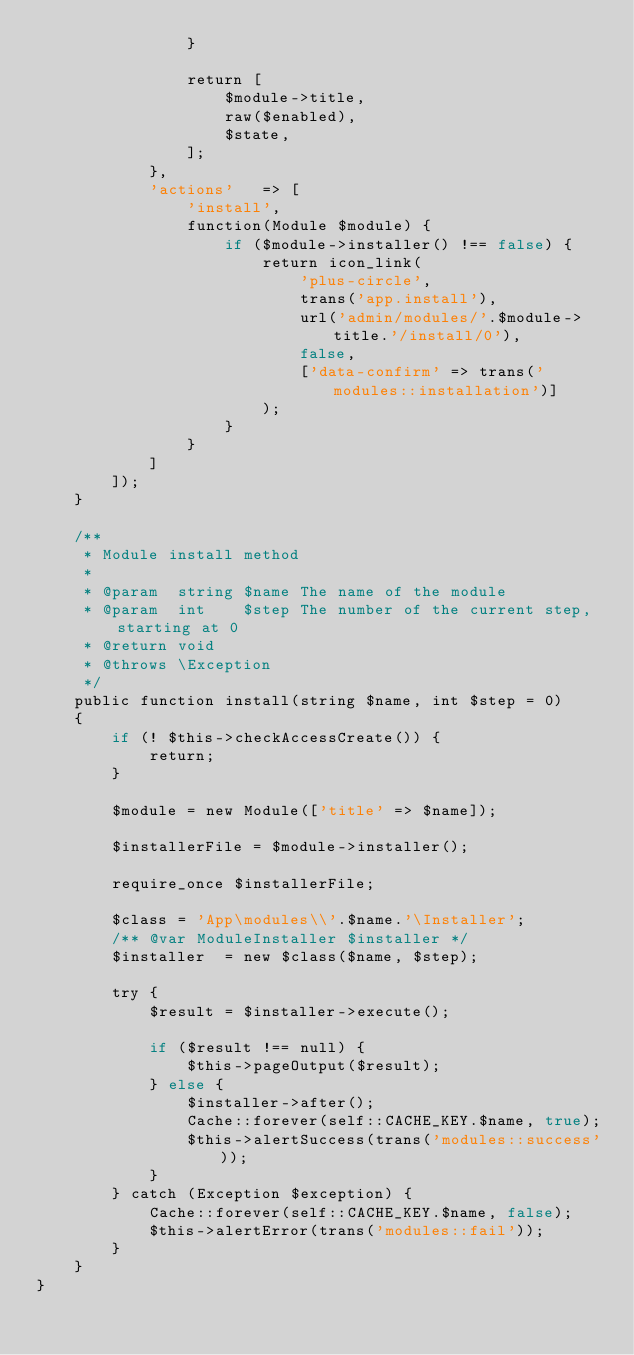Convert code to text. <code><loc_0><loc_0><loc_500><loc_500><_PHP_>                }

                return [
                    $module->title,
                    raw($enabled),
                    $state,
                ];
            },
            'actions'   => [
                'install',
                function(Module $module) {
                    if ($module->installer() !== false) {
                        return icon_link(
                            'plus-circle',
                            trans('app.install'), 
                            url('admin/modules/'.$module->title.'/install/0'),
                            false,
                            ['data-confirm' => trans('modules::installation')]
                        );
                    }
                }
            ]
        ]);
    }

    /**
     * Module install method
     *
     * @param  string $name The name of the module
     * @param  int    $step The number of the current step, starting at 0
     * @return void
     * @throws \Exception
     */
    public function install(string $name, int $step = 0)
    {
        if (! $this->checkAccessCreate()) {
            return;
        }

        $module = new Module(['title' => $name]);

        $installerFile = $module->installer();

        require_once $installerFile;

        $class = 'App\modules\\'.$name.'\Installer';
        /** @var ModuleInstaller $installer */
        $installer  = new $class($name, $step);

        try {
            $result = $installer->execute();

            if ($result !== null) {
                $this->pageOutput($result);
            } else {
                $installer->after();
                Cache::forever(self::CACHE_KEY.$name, true);
                $this->alertSuccess(trans('modules::success'));
            }
        } catch (Exception $exception) {
            Cache::forever(self::CACHE_KEY.$name, false);
            $this->alertError(trans('modules::fail'));
        }
    }
}
</code> 